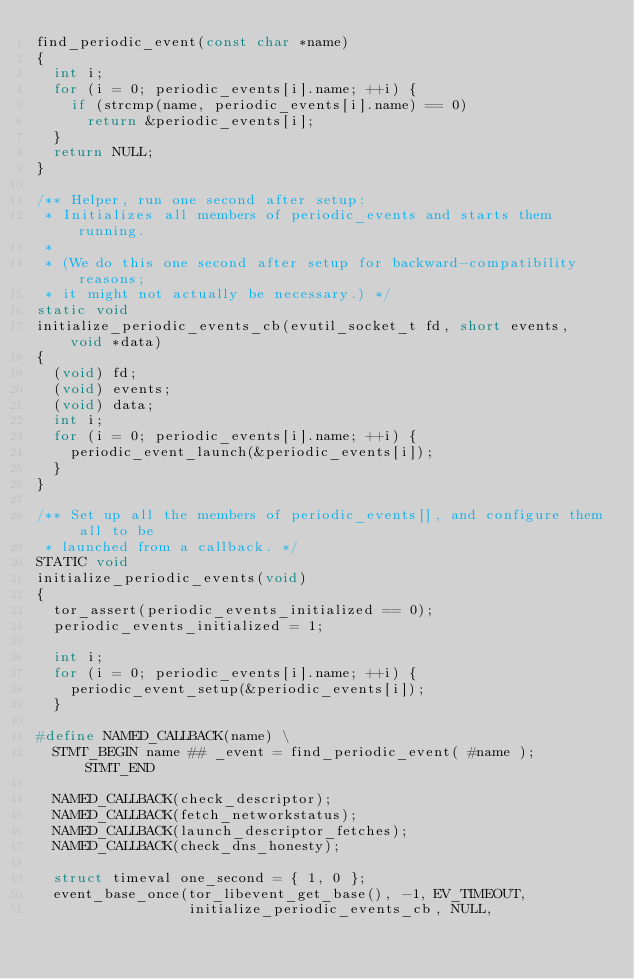<code> <loc_0><loc_0><loc_500><loc_500><_C_>find_periodic_event(const char *name)
{
  int i;
  for (i = 0; periodic_events[i].name; ++i) {
    if (strcmp(name, periodic_events[i].name) == 0)
      return &periodic_events[i];
  }
  return NULL;
}

/** Helper, run one second after setup:
 * Initializes all members of periodic_events and starts them running.
 *
 * (We do this one second after setup for backward-compatibility reasons;
 * it might not actually be necessary.) */
static void
initialize_periodic_events_cb(evutil_socket_t fd, short events, void *data)
{
  (void) fd;
  (void) events;
  (void) data;
  int i;
  for (i = 0; periodic_events[i].name; ++i) {
    periodic_event_launch(&periodic_events[i]);
  }
}

/** Set up all the members of periodic_events[], and configure them all to be
 * launched from a callback. */
STATIC void
initialize_periodic_events(void)
{
  tor_assert(periodic_events_initialized == 0);
  periodic_events_initialized = 1;

  int i;
  for (i = 0; periodic_events[i].name; ++i) {
    periodic_event_setup(&periodic_events[i]);
  }

#define NAMED_CALLBACK(name) \
  STMT_BEGIN name ## _event = find_periodic_event( #name ); STMT_END

  NAMED_CALLBACK(check_descriptor);
  NAMED_CALLBACK(fetch_networkstatus);
  NAMED_CALLBACK(launch_descriptor_fetches);
  NAMED_CALLBACK(check_dns_honesty);

  struct timeval one_second = { 1, 0 };
  event_base_once(tor_libevent_get_base(), -1, EV_TIMEOUT,
                  initialize_periodic_events_cb, NULL,</code> 